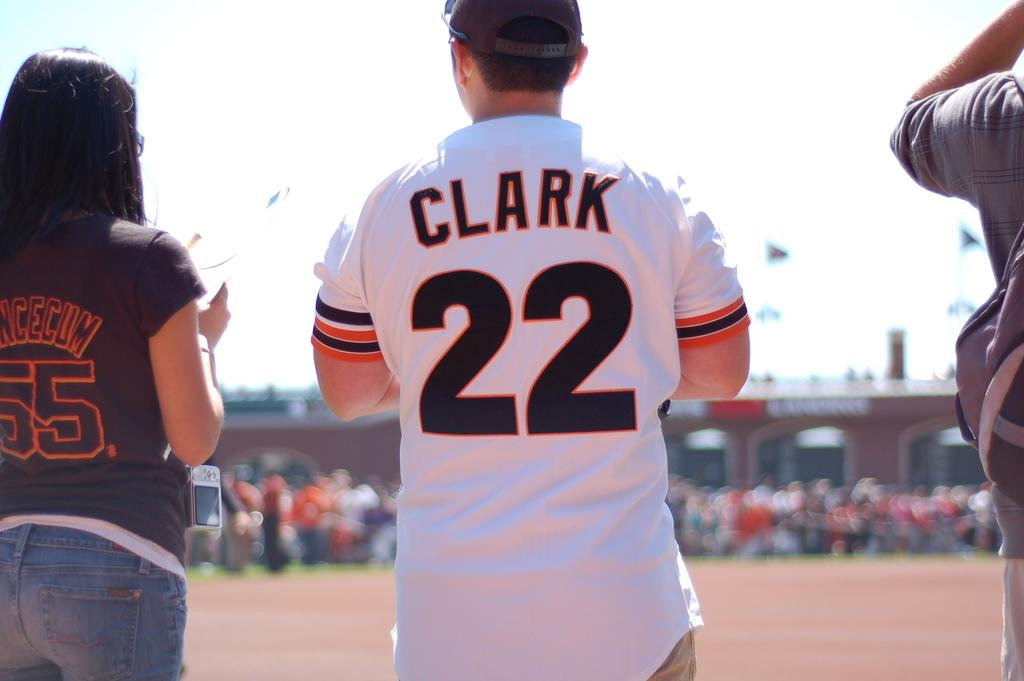How many people are in the image? There are three members in the image. Where are the members standing? The members are standing on the land. Can you describe the background of the image? The background of the image is blurred. What downtown attraction can be seen in the image? There is no downtown attraction present in the image. How long does it take for the members to move from one side of the land to the other in the image? The image is a still photograph, so the members are not moving, and therefore it is not possible to determine how long it would take for them to move from one side of the land to the other. 